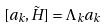Convert formula to latex. <formula><loc_0><loc_0><loc_500><loc_500>[ a _ { k } , \tilde { H } ] = \Lambda _ { k } a _ { k }</formula> 